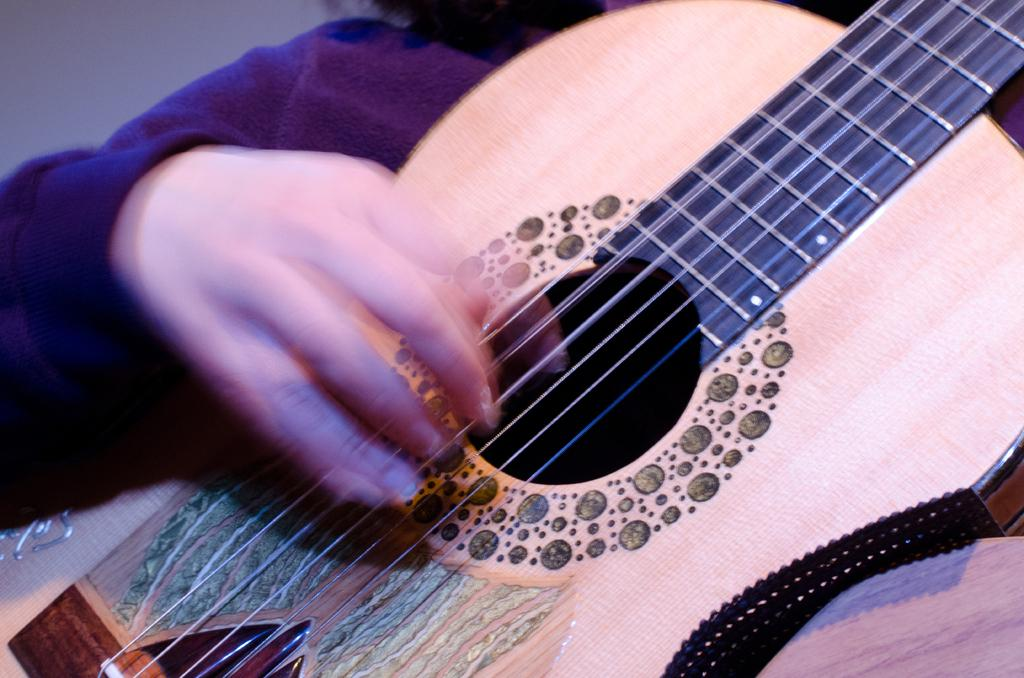What is the main subject of the image? The main subject of the image is a person. What is the person doing in the image? The person is playing a guitar. What type of trees can be seen in the background of the image? There is no background or trees present in the image; it only features a person playing a guitar. 